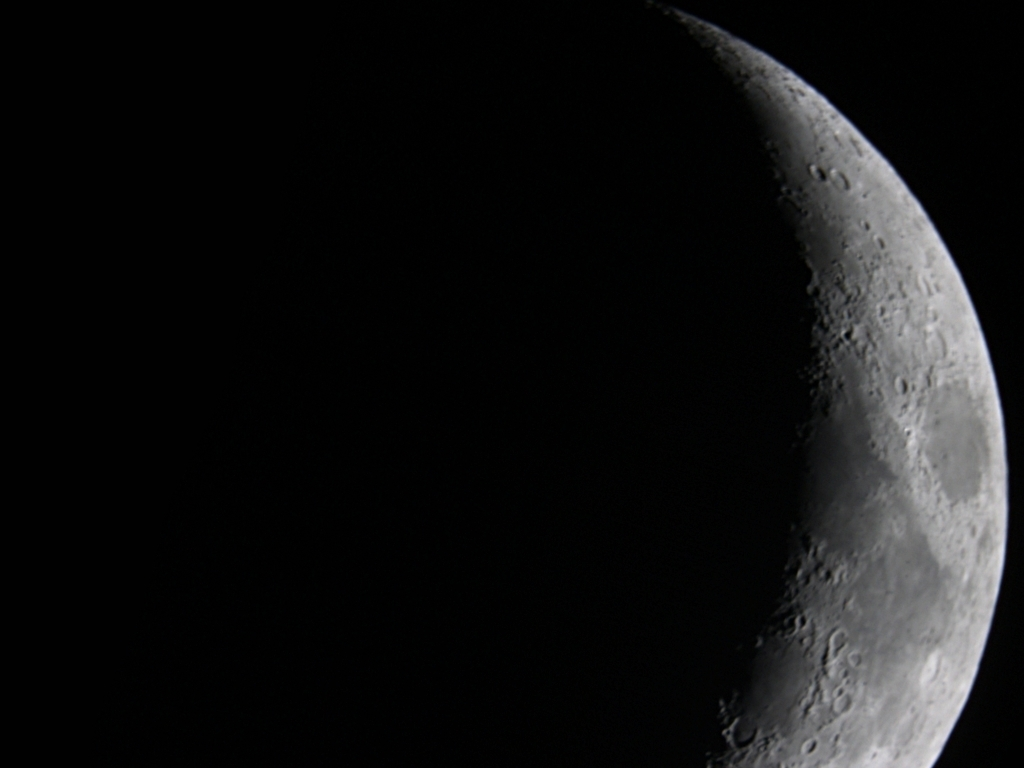Can you describe the variation in crater sizes seen on the moon in this image? The moon's surface in the image shows a wide variety of crater sizes, from small pits to large basins. The larger craters are likely older, having been exposed to more impacts over time, while smaller craters may be relatively recent. The variation in size contributes to the complex texture and geological history evident on the lunar surface. 